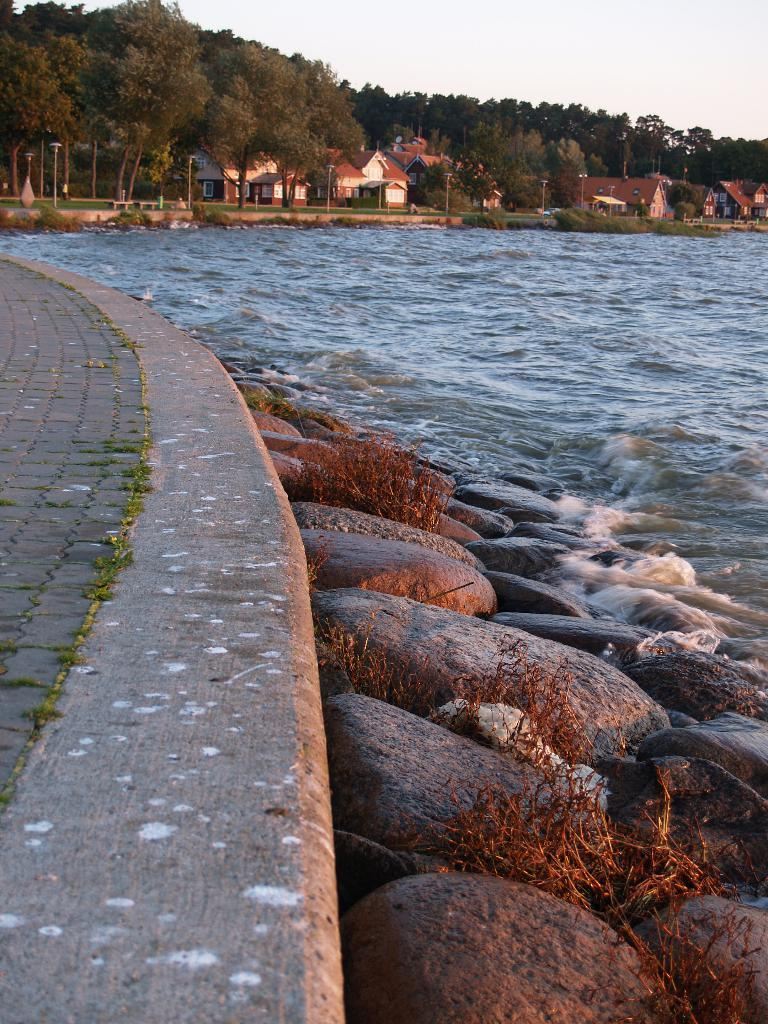What can be seen on the left side of the image? There is a path on the left side of the image. What is located on the right side of the image? There is a beach on the right side of the image. What type of structures are visible in the background of the image? There are homes visible in the background of the image. What type of vegetation is present in front of the homes? Trees are present in front of the homes. What is visible above the scene in the image? The sky is visible above the scene. Can you tell me how many aunts are sitting on the beach in the image? There are no aunts present in the image; it features a path, beach, homes, trees, and sky. What type of beef is being served at the beach in the image? There is no beef present in the image; it features a path, beach, homes, trees, and sky. 